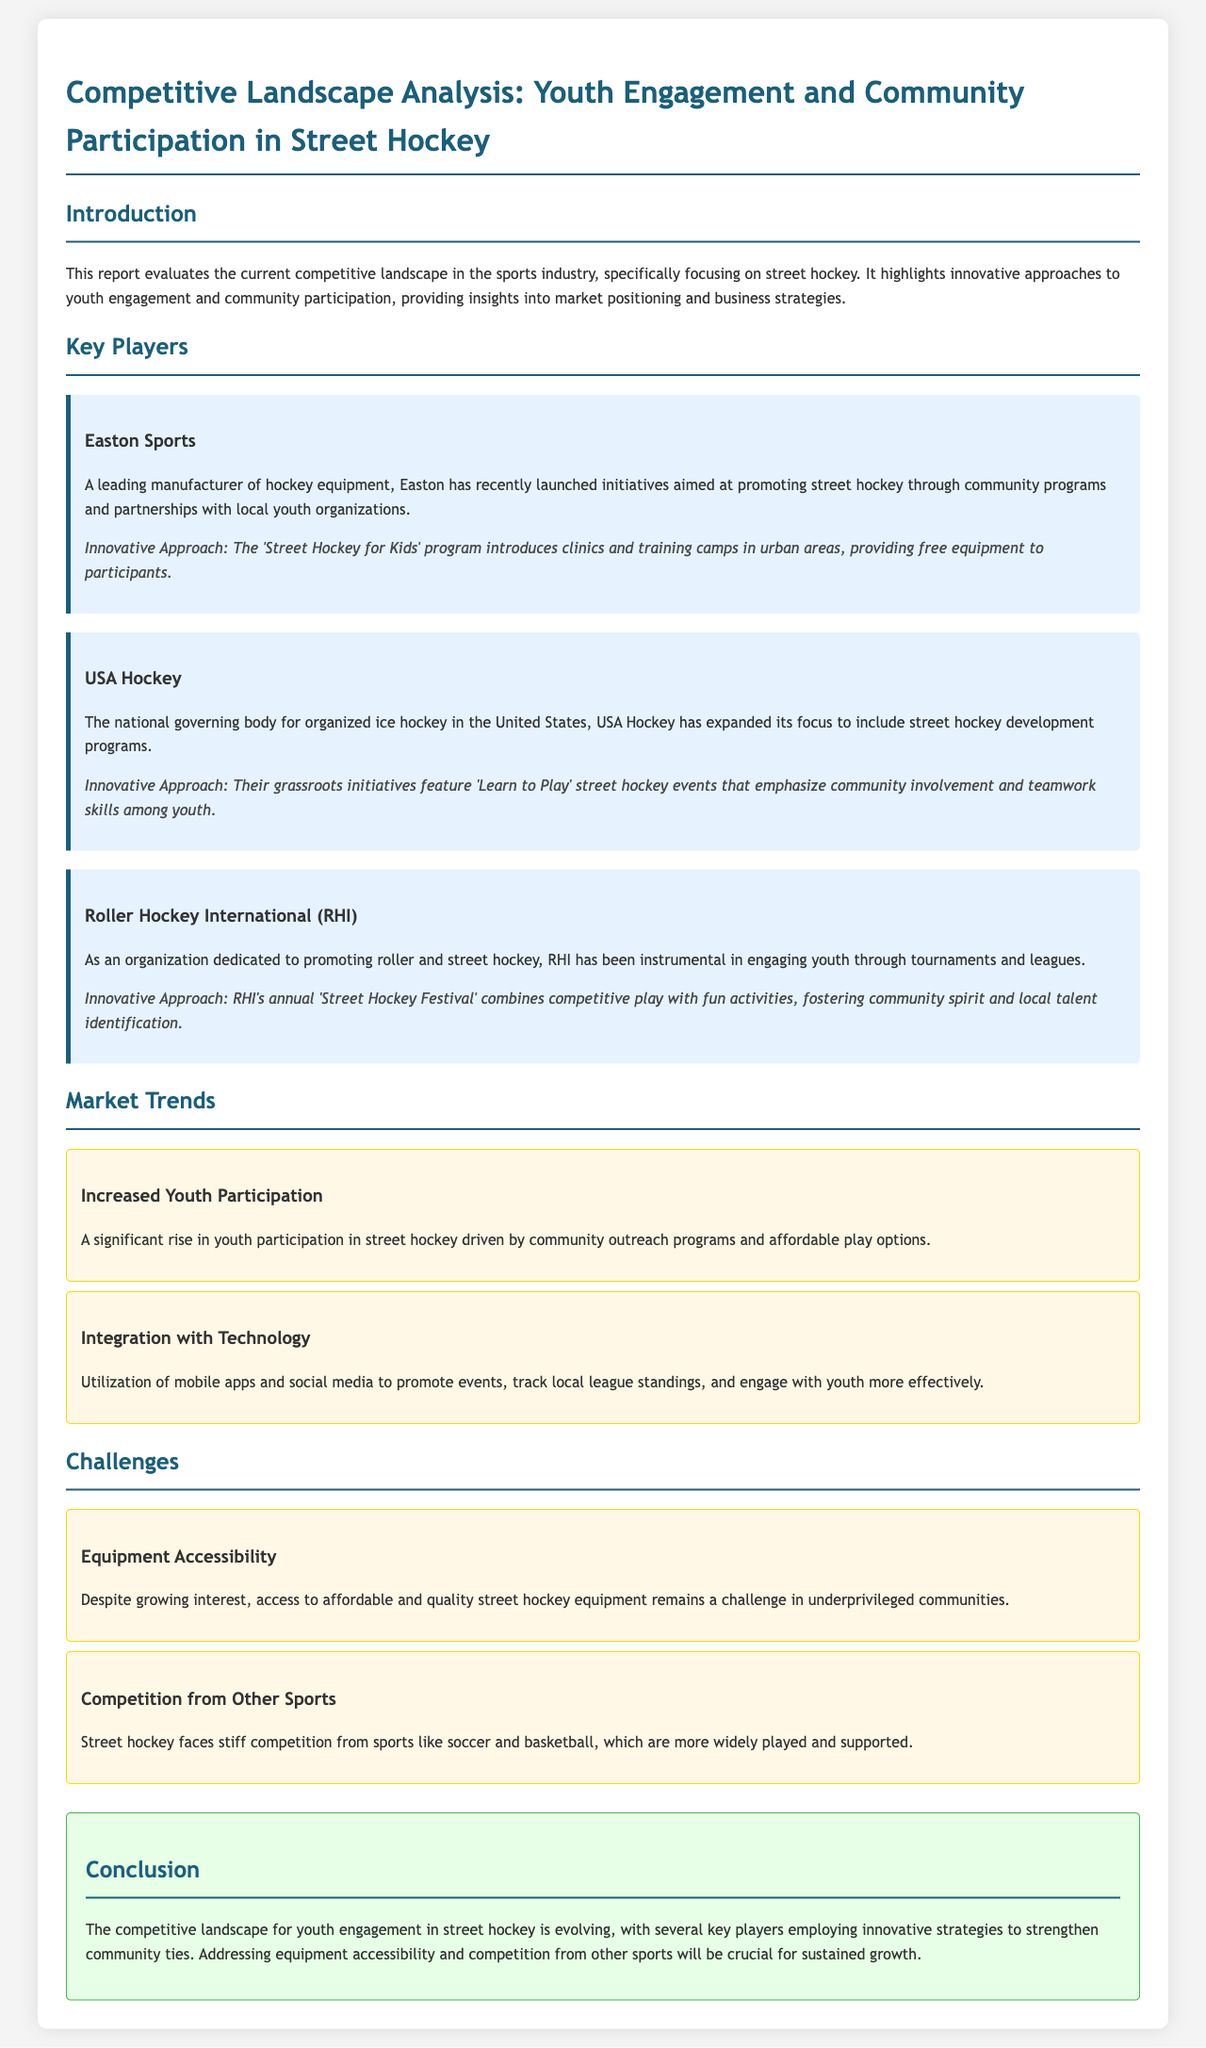What is the title of the report? The title of the report is presented in the header section of the document.
Answer: Competitive Landscape Analysis: Youth Engagement and Community Participation in Street Hockey Who is a key player focused on promoting street hockey? The document lists several key players involved in street hockey initiatives.
Answer: Easton Sports What innovative approach is used by USA Hockey? The document describes specific initiatives by key players and highlights their innovative approaches.
Answer: 'Learn to Play' street hockey events What is the annual event organized by Roller Hockey International? The document mentions an annual event to foster community spirit among youth.
Answer: 'Street Hockey Festival' What is one challenge faced by the street hockey community? The challenges section of the document outlines problems that hinder growth in street hockey engagement.
Answer: Equipment Accessibility How has youth participation in street hockey changed? The trends section indicates significant developments in participation levels due to outreach efforts.
Answer: Increased Youth Participation What technology integration is mentioned in the document? The report discusses various trends affecting street hockey and mentions how technology plays a role.
Answer: Mobile apps and social media 